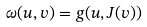Convert formula to latex. <formula><loc_0><loc_0><loc_500><loc_500>\omega ( u , v ) = g ( u , J ( v ) )</formula> 